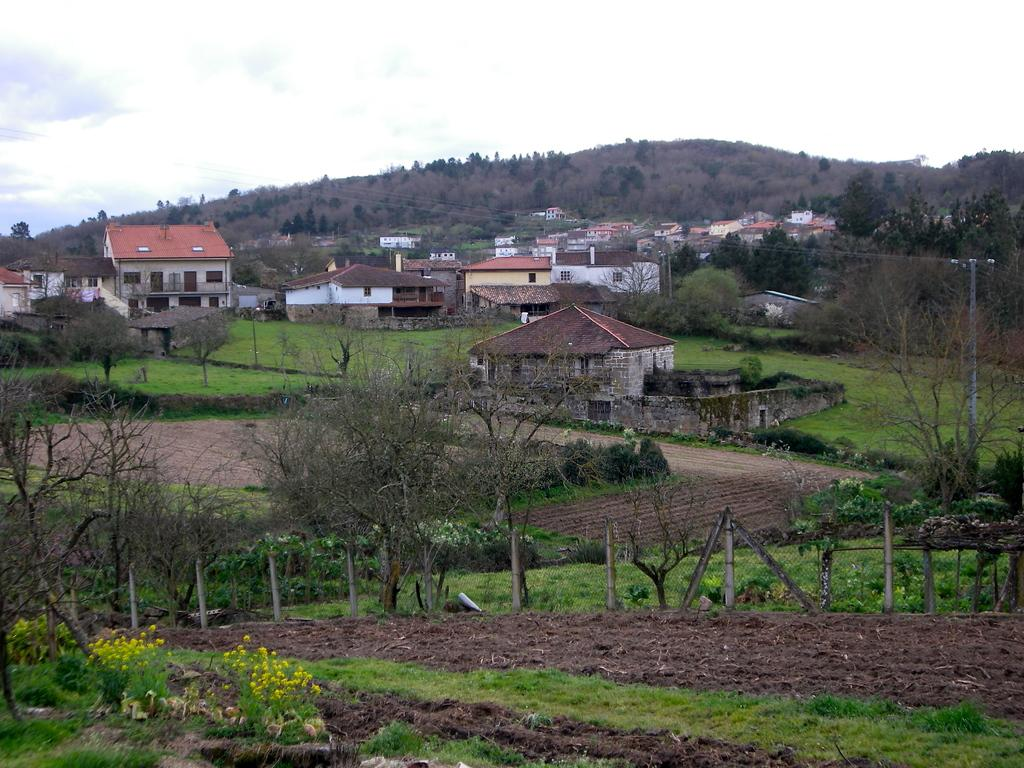What type of structures can be seen in the image? There are houses in the image. What can be seen beneath the houses and other objects in the image? The ground is visible in the image. What type of vegetation is present in the image? There is grass, plants, and trees in the image. What are the tall, thin objects in the image? There are poles in the image. What type of natural formation can be seen in the image? There are hills in the image. What is visible above the houses and other objects in the image? The sky is visible in the image. Can you see the seashore in the image? No, there is no seashore visible in the image. What is the father doing in the image? There is no father present in the image, so it is not possible to answer that question. 